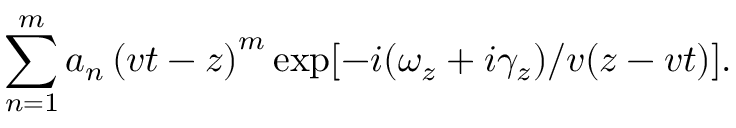Convert formula to latex. <formula><loc_0><loc_0><loc_500><loc_500>\sum _ { n = 1 } ^ { m } a _ { n } \left ( v t - z \right ) ^ { m } \exp [ - i ( \omega _ { z } + i \gamma _ { z } ) / v ( z - v t ) ] .</formula> 